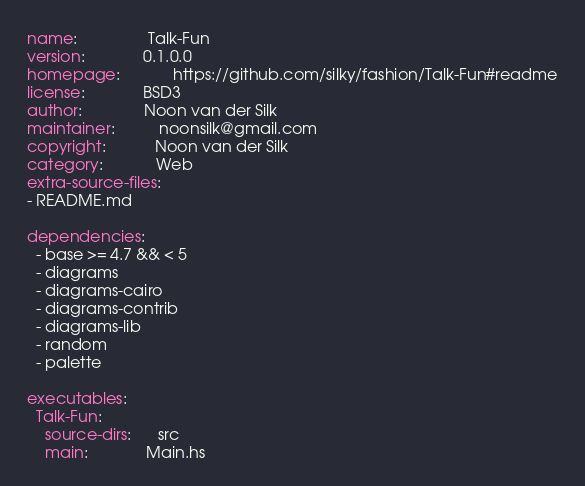<code> <loc_0><loc_0><loc_500><loc_500><_YAML_>name:                Talk-Fun
version:             0.1.0.0
homepage:            https://github.com/silky/fashion/Talk-Fun#readme
license:             BSD3
author:              Noon van der Silk
maintainer:          noonsilk@gmail.com
copyright:           Noon van der Silk
category:            Web
extra-source-files:
- README.md

dependencies:
  - base >= 4.7 && < 5
  - diagrams
  - diagrams-cairo
  - diagrams-contrib
  - diagrams-lib
  - random
  - palette

executables:
  Talk-Fun:
    source-dirs:      src
    main:             Main.hs
</code> 